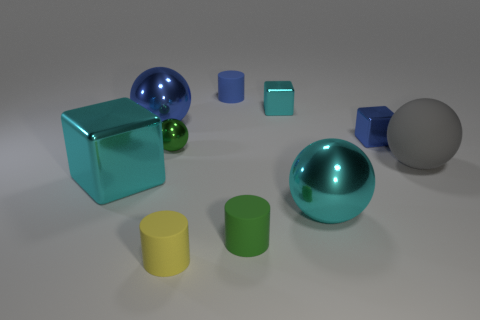Is the number of small blue objects that are in front of the small sphere the same as the number of small blue matte things?
Ensure brevity in your answer.  No. What is the small blue thing behind the blue object right of the cyan metal cube right of the small yellow object made of?
Ensure brevity in your answer.  Rubber. There is a large blue thing that is the same material as the green ball; what shape is it?
Offer a very short reply. Sphere. Is there any other thing that has the same color as the large rubber object?
Keep it short and to the point. No. How many tiny things are left of the cylinder that is in front of the green object that is in front of the big gray rubber thing?
Your answer should be compact. 1. How many cyan objects are either large objects or metal cubes?
Ensure brevity in your answer.  3. Is the size of the rubber ball the same as the green shiny ball behind the big cube?
Provide a succinct answer. No. There is a big gray object that is the same shape as the big blue object; what material is it?
Make the answer very short. Rubber. What number of other objects are there of the same size as the green cylinder?
Provide a short and direct response. 5. What shape is the cyan metal thing left of the green thing that is behind the sphere right of the blue metallic block?
Give a very brief answer. Cube. 